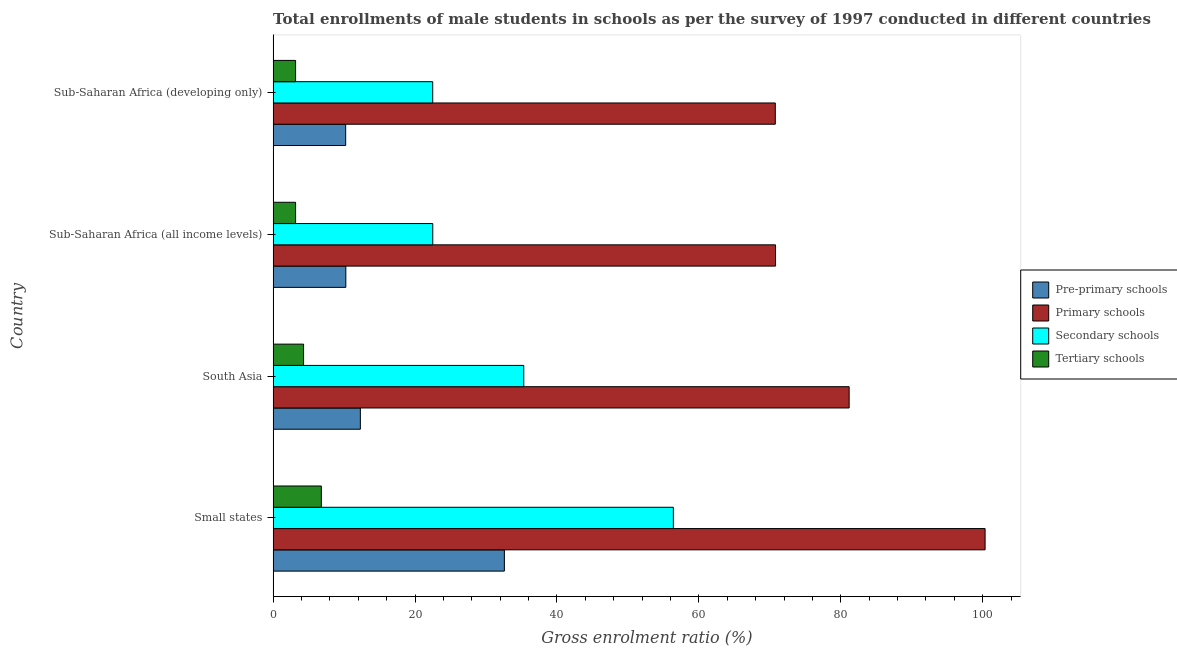How many different coloured bars are there?
Provide a short and direct response. 4. How many groups of bars are there?
Offer a very short reply. 4. Are the number of bars per tick equal to the number of legend labels?
Your response must be concise. Yes. Are the number of bars on each tick of the Y-axis equal?
Offer a terse response. Yes. How many bars are there on the 1st tick from the bottom?
Make the answer very short. 4. What is the label of the 3rd group of bars from the top?
Make the answer very short. South Asia. In how many cases, is the number of bars for a given country not equal to the number of legend labels?
Make the answer very short. 0. What is the gross enrolment ratio(male) in pre-primary schools in Sub-Saharan Africa (all income levels)?
Your answer should be compact. 10.25. Across all countries, what is the maximum gross enrolment ratio(male) in pre-primary schools?
Your answer should be very brief. 32.59. Across all countries, what is the minimum gross enrolment ratio(male) in pre-primary schools?
Your answer should be compact. 10.22. In which country was the gross enrolment ratio(male) in tertiary schools maximum?
Provide a short and direct response. Small states. In which country was the gross enrolment ratio(male) in pre-primary schools minimum?
Provide a short and direct response. Sub-Saharan Africa (developing only). What is the total gross enrolment ratio(male) in pre-primary schools in the graph?
Ensure brevity in your answer.  65.36. What is the difference between the gross enrolment ratio(male) in primary schools in Small states and that in Sub-Saharan Africa (all income levels)?
Provide a short and direct response. 29.53. What is the difference between the gross enrolment ratio(male) in pre-primary schools in Sub-Saharan Africa (all income levels) and the gross enrolment ratio(male) in primary schools in Sub-Saharan Africa (developing only)?
Give a very brief answer. -60.52. What is the average gross enrolment ratio(male) in pre-primary schools per country?
Provide a short and direct response. 16.34. What is the difference between the gross enrolment ratio(male) in tertiary schools and gross enrolment ratio(male) in secondary schools in Sub-Saharan Africa (developing only)?
Make the answer very short. -19.32. Is the difference between the gross enrolment ratio(male) in pre-primary schools in South Asia and Sub-Saharan Africa (all income levels) greater than the difference between the gross enrolment ratio(male) in secondary schools in South Asia and Sub-Saharan Africa (all income levels)?
Your response must be concise. No. What is the difference between the highest and the second highest gross enrolment ratio(male) in primary schools?
Offer a terse response. 19.16. What is the difference between the highest and the lowest gross enrolment ratio(male) in primary schools?
Your answer should be very brief. 29.57. In how many countries, is the gross enrolment ratio(male) in secondary schools greater than the average gross enrolment ratio(male) in secondary schools taken over all countries?
Provide a short and direct response. 2. What does the 4th bar from the top in South Asia represents?
Offer a terse response. Pre-primary schools. What does the 4th bar from the bottom in South Asia represents?
Provide a succinct answer. Tertiary schools. Is it the case that in every country, the sum of the gross enrolment ratio(male) in pre-primary schools and gross enrolment ratio(male) in primary schools is greater than the gross enrolment ratio(male) in secondary schools?
Provide a short and direct response. Yes. Are the values on the major ticks of X-axis written in scientific E-notation?
Give a very brief answer. No. Does the graph contain any zero values?
Offer a terse response. No. Where does the legend appear in the graph?
Provide a short and direct response. Center right. What is the title of the graph?
Your answer should be compact. Total enrollments of male students in schools as per the survey of 1997 conducted in different countries. Does "Public sector management" appear as one of the legend labels in the graph?
Your answer should be compact. No. What is the label or title of the X-axis?
Your response must be concise. Gross enrolment ratio (%). What is the label or title of the Y-axis?
Provide a short and direct response. Country. What is the Gross enrolment ratio (%) of Pre-primary schools in Small states?
Offer a very short reply. 32.59. What is the Gross enrolment ratio (%) in Primary schools in Small states?
Your answer should be compact. 100.33. What is the Gross enrolment ratio (%) of Secondary schools in Small states?
Offer a very short reply. 56.4. What is the Gross enrolment ratio (%) of Tertiary schools in Small states?
Your answer should be very brief. 6.79. What is the Gross enrolment ratio (%) of Pre-primary schools in South Asia?
Offer a very short reply. 12.29. What is the Gross enrolment ratio (%) of Primary schools in South Asia?
Ensure brevity in your answer.  81.18. What is the Gross enrolment ratio (%) in Secondary schools in South Asia?
Your answer should be very brief. 35.32. What is the Gross enrolment ratio (%) in Tertiary schools in South Asia?
Provide a short and direct response. 4.29. What is the Gross enrolment ratio (%) in Pre-primary schools in Sub-Saharan Africa (all income levels)?
Make the answer very short. 10.25. What is the Gross enrolment ratio (%) of Primary schools in Sub-Saharan Africa (all income levels)?
Your answer should be very brief. 70.8. What is the Gross enrolment ratio (%) in Secondary schools in Sub-Saharan Africa (all income levels)?
Your answer should be very brief. 22.5. What is the Gross enrolment ratio (%) of Tertiary schools in Sub-Saharan Africa (all income levels)?
Your response must be concise. 3.17. What is the Gross enrolment ratio (%) in Pre-primary schools in Sub-Saharan Africa (developing only)?
Provide a succinct answer. 10.22. What is the Gross enrolment ratio (%) in Primary schools in Sub-Saharan Africa (developing only)?
Make the answer very short. 70.77. What is the Gross enrolment ratio (%) of Secondary schools in Sub-Saharan Africa (developing only)?
Provide a succinct answer. 22.49. What is the Gross enrolment ratio (%) of Tertiary schools in Sub-Saharan Africa (developing only)?
Ensure brevity in your answer.  3.17. Across all countries, what is the maximum Gross enrolment ratio (%) of Pre-primary schools?
Give a very brief answer. 32.59. Across all countries, what is the maximum Gross enrolment ratio (%) in Primary schools?
Provide a short and direct response. 100.33. Across all countries, what is the maximum Gross enrolment ratio (%) in Secondary schools?
Give a very brief answer. 56.4. Across all countries, what is the maximum Gross enrolment ratio (%) in Tertiary schools?
Provide a short and direct response. 6.79. Across all countries, what is the minimum Gross enrolment ratio (%) of Pre-primary schools?
Ensure brevity in your answer.  10.22. Across all countries, what is the minimum Gross enrolment ratio (%) in Primary schools?
Make the answer very short. 70.77. Across all countries, what is the minimum Gross enrolment ratio (%) in Secondary schools?
Offer a terse response. 22.49. Across all countries, what is the minimum Gross enrolment ratio (%) of Tertiary schools?
Ensure brevity in your answer.  3.17. What is the total Gross enrolment ratio (%) in Pre-primary schools in the graph?
Your answer should be very brief. 65.36. What is the total Gross enrolment ratio (%) of Primary schools in the graph?
Your response must be concise. 323.08. What is the total Gross enrolment ratio (%) in Secondary schools in the graph?
Provide a succinct answer. 136.71. What is the total Gross enrolment ratio (%) of Tertiary schools in the graph?
Give a very brief answer. 17.42. What is the difference between the Gross enrolment ratio (%) of Pre-primary schools in Small states and that in South Asia?
Your answer should be very brief. 20.29. What is the difference between the Gross enrolment ratio (%) in Primary schools in Small states and that in South Asia?
Offer a very short reply. 19.16. What is the difference between the Gross enrolment ratio (%) of Secondary schools in Small states and that in South Asia?
Your answer should be compact. 21.08. What is the difference between the Gross enrolment ratio (%) in Tertiary schools in Small states and that in South Asia?
Your response must be concise. 2.5. What is the difference between the Gross enrolment ratio (%) in Pre-primary schools in Small states and that in Sub-Saharan Africa (all income levels)?
Offer a very short reply. 22.34. What is the difference between the Gross enrolment ratio (%) of Primary schools in Small states and that in Sub-Saharan Africa (all income levels)?
Give a very brief answer. 29.53. What is the difference between the Gross enrolment ratio (%) of Secondary schools in Small states and that in Sub-Saharan Africa (all income levels)?
Ensure brevity in your answer.  33.91. What is the difference between the Gross enrolment ratio (%) in Tertiary schools in Small states and that in Sub-Saharan Africa (all income levels)?
Give a very brief answer. 3.63. What is the difference between the Gross enrolment ratio (%) of Pre-primary schools in Small states and that in Sub-Saharan Africa (developing only)?
Your response must be concise. 22.36. What is the difference between the Gross enrolment ratio (%) of Primary schools in Small states and that in Sub-Saharan Africa (developing only)?
Give a very brief answer. 29.57. What is the difference between the Gross enrolment ratio (%) of Secondary schools in Small states and that in Sub-Saharan Africa (developing only)?
Your answer should be compact. 33.91. What is the difference between the Gross enrolment ratio (%) of Tertiary schools in Small states and that in Sub-Saharan Africa (developing only)?
Ensure brevity in your answer.  3.63. What is the difference between the Gross enrolment ratio (%) of Pre-primary schools in South Asia and that in Sub-Saharan Africa (all income levels)?
Give a very brief answer. 2.05. What is the difference between the Gross enrolment ratio (%) of Primary schools in South Asia and that in Sub-Saharan Africa (all income levels)?
Your answer should be compact. 10.37. What is the difference between the Gross enrolment ratio (%) in Secondary schools in South Asia and that in Sub-Saharan Africa (all income levels)?
Offer a terse response. 12.82. What is the difference between the Gross enrolment ratio (%) of Tertiary schools in South Asia and that in Sub-Saharan Africa (all income levels)?
Your answer should be very brief. 1.13. What is the difference between the Gross enrolment ratio (%) of Pre-primary schools in South Asia and that in Sub-Saharan Africa (developing only)?
Provide a short and direct response. 2.07. What is the difference between the Gross enrolment ratio (%) of Primary schools in South Asia and that in Sub-Saharan Africa (developing only)?
Make the answer very short. 10.41. What is the difference between the Gross enrolment ratio (%) in Secondary schools in South Asia and that in Sub-Saharan Africa (developing only)?
Ensure brevity in your answer.  12.83. What is the difference between the Gross enrolment ratio (%) of Tertiary schools in South Asia and that in Sub-Saharan Africa (developing only)?
Give a very brief answer. 1.12. What is the difference between the Gross enrolment ratio (%) in Pre-primary schools in Sub-Saharan Africa (all income levels) and that in Sub-Saharan Africa (developing only)?
Offer a very short reply. 0.02. What is the difference between the Gross enrolment ratio (%) in Primary schools in Sub-Saharan Africa (all income levels) and that in Sub-Saharan Africa (developing only)?
Offer a terse response. 0.03. What is the difference between the Gross enrolment ratio (%) in Secondary schools in Sub-Saharan Africa (all income levels) and that in Sub-Saharan Africa (developing only)?
Your answer should be compact. 0.01. What is the difference between the Gross enrolment ratio (%) in Tertiary schools in Sub-Saharan Africa (all income levels) and that in Sub-Saharan Africa (developing only)?
Ensure brevity in your answer.  -0. What is the difference between the Gross enrolment ratio (%) of Pre-primary schools in Small states and the Gross enrolment ratio (%) of Primary schools in South Asia?
Make the answer very short. -48.59. What is the difference between the Gross enrolment ratio (%) in Pre-primary schools in Small states and the Gross enrolment ratio (%) in Secondary schools in South Asia?
Offer a very short reply. -2.73. What is the difference between the Gross enrolment ratio (%) in Pre-primary schools in Small states and the Gross enrolment ratio (%) in Tertiary schools in South Asia?
Ensure brevity in your answer.  28.3. What is the difference between the Gross enrolment ratio (%) of Primary schools in Small states and the Gross enrolment ratio (%) of Secondary schools in South Asia?
Offer a terse response. 65.01. What is the difference between the Gross enrolment ratio (%) in Primary schools in Small states and the Gross enrolment ratio (%) in Tertiary schools in South Asia?
Provide a short and direct response. 96.04. What is the difference between the Gross enrolment ratio (%) of Secondary schools in Small states and the Gross enrolment ratio (%) of Tertiary schools in South Asia?
Your answer should be compact. 52.11. What is the difference between the Gross enrolment ratio (%) in Pre-primary schools in Small states and the Gross enrolment ratio (%) in Primary schools in Sub-Saharan Africa (all income levels)?
Keep it short and to the point. -38.21. What is the difference between the Gross enrolment ratio (%) of Pre-primary schools in Small states and the Gross enrolment ratio (%) of Secondary schools in Sub-Saharan Africa (all income levels)?
Your answer should be compact. 10.09. What is the difference between the Gross enrolment ratio (%) of Pre-primary schools in Small states and the Gross enrolment ratio (%) of Tertiary schools in Sub-Saharan Africa (all income levels)?
Give a very brief answer. 29.42. What is the difference between the Gross enrolment ratio (%) of Primary schools in Small states and the Gross enrolment ratio (%) of Secondary schools in Sub-Saharan Africa (all income levels)?
Make the answer very short. 77.84. What is the difference between the Gross enrolment ratio (%) of Primary schools in Small states and the Gross enrolment ratio (%) of Tertiary schools in Sub-Saharan Africa (all income levels)?
Make the answer very short. 97.17. What is the difference between the Gross enrolment ratio (%) of Secondary schools in Small states and the Gross enrolment ratio (%) of Tertiary schools in Sub-Saharan Africa (all income levels)?
Provide a succinct answer. 53.24. What is the difference between the Gross enrolment ratio (%) in Pre-primary schools in Small states and the Gross enrolment ratio (%) in Primary schools in Sub-Saharan Africa (developing only)?
Your answer should be compact. -38.18. What is the difference between the Gross enrolment ratio (%) of Pre-primary schools in Small states and the Gross enrolment ratio (%) of Secondary schools in Sub-Saharan Africa (developing only)?
Your answer should be very brief. 10.1. What is the difference between the Gross enrolment ratio (%) of Pre-primary schools in Small states and the Gross enrolment ratio (%) of Tertiary schools in Sub-Saharan Africa (developing only)?
Offer a very short reply. 29.42. What is the difference between the Gross enrolment ratio (%) in Primary schools in Small states and the Gross enrolment ratio (%) in Secondary schools in Sub-Saharan Africa (developing only)?
Your answer should be compact. 77.84. What is the difference between the Gross enrolment ratio (%) of Primary schools in Small states and the Gross enrolment ratio (%) of Tertiary schools in Sub-Saharan Africa (developing only)?
Give a very brief answer. 97.17. What is the difference between the Gross enrolment ratio (%) in Secondary schools in Small states and the Gross enrolment ratio (%) in Tertiary schools in Sub-Saharan Africa (developing only)?
Provide a succinct answer. 53.24. What is the difference between the Gross enrolment ratio (%) of Pre-primary schools in South Asia and the Gross enrolment ratio (%) of Primary schools in Sub-Saharan Africa (all income levels)?
Give a very brief answer. -58.51. What is the difference between the Gross enrolment ratio (%) in Pre-primary schools in South Asia and the Gross enrolment ratio (%) in Secondary schools in Sub-Saharan Africa (all income levels)?
Offer a very short reply. -10.2. What is the difference between the Gross enrolment ratio (%) in Pre-primary schools in South Asia and the Gross enrolment ratio (%) in Tertiary schools in Sub-Saharan Africa (all income levels)?
Provide a short and direct response. 9.13. What is the difference between the Gross enrolment ratio (%) of Primary schools in South Asia and the Gross enrolment ratio (%) of Secondary schools in Sub-Saharan Africa (all income levels)?
Your response must be concise. 58.68. What is the difference between the Gross enrolment ratio (%) in Primary schools in South Asia and the Gross enrolment ratio (%) in Tertiary schools in Sub-Saharan Africa (all income levels)?
Provide a short and direct response. 78.01. What is the difference between the Gross enrolment ratio (%) of Secondary schools in South Asia and the Gross enrolment ratio (%) of Tertiary schools in Sub-Saharan Africa (all income levels)?
Keep it short and to the point. 32.16. What is the difference between the Gross enrolment ratio (%) in Pre-primary schools in South Asia and the Gross enrolment ratio (%) in Primary schools in Sub-Saharan Africa (developing only)?
Offer a terse response. -58.47. What is the difference between the Gross enrolment ratio (%) in Pre-primary schools in South Asia and the Gross enrolment ratio (%) in Secondary schools in Sub-Saharan Africa (developing only)?
Your response must be concise. -10.2. What is the difference between the Gross enrolment ratio (%) of Pre-primary schools in South Asia and the Gross enrolment ratio (%) of Tertiary schools in Sub-Saharan Africa (developing only)?
Ensure brevity in your answer.  9.13. What is the difference between the Gross enrolment ratio (%) of Primary schools in South Asia and the Gross enrolment ratio (%) of Secondary schools in Sub-Saharan Africa (developing only)?
Offer a very short reply. 58.69. What is the difference between the Gross enrolment ratio (%) of Primary schools in South Asia and the Gross enrolment ratio (%) of Tertiary schools in Sub-Saharan Africa (developing only)?
Keep it short and to the point. 78.01. What is the difference between the Gross enrolment ratio (%) of Secondary schools in South Asia and the Gross enrolment ratio (%) of Tertiary schools in Sub-Saharan Africa (developing only)?
Offer a very short reply. 32.16. What is the difference between the Gross enrolment ratio (%) in Pre-primary schools in Sub-Saharan Africa (all income levels) and the Gross enrolment ratio (%) in Primary schools in Sub-Saharan Africa (developing only)?
Your answer should be compact. -60.52. What is the difference between the Gross enrolment ratio (%) of Pre-primary schools in Sub-Saharan Africa (all income levels) and the Gross enrolment ratio (%) of Secondary schools in Sub-Saharan Africa (developing only)?
Make the answer very short. -12.24. What is the difference between the Gross enrolment ratio (%) of Pre-primary schools in Sub-Saharan Africa (all income levels) and the Gross enrolment ratio (%) of Tertiary schools in Sub-Saharan Africa (developing only)?
Provide a succinct answer. 7.08. What is the difference between the Gross enrolment ratio (%) in Primary schools in Sub-Saharan Africa (all income levels) and the Gross enrolment ratio (%) in Secondary schools in Sub-Saharan Africa (developing only)?
Ensure brevity in your answer.  48.31. What is the difference between the Gross enrolment ratio (%) of Primary schools in Sub-Saharan Africa (all income levels) and the Gross enrolment ratio (%) of Tertiary schools in Sub-Saharan Africa (developing only)?
Offer a terse response. 67.64. What is the difference between the Gross enrolment ratio (%) in Secondary schools in Sub-Saharan Africa (all income levels) and the Gross enrolment ratio (%) in Tertiary schools in Sub-Saharan Africa (developing only)?
Offer a terse response. 19.33. What is the average Gross enrolment ratio (%) in Pre-primary schools per country?
Give a very brief answer. 16.34. What is the average Gross enrolment ratio (%) in Primary schools per country?
Give a very brief answer. 80.77. What is the average Gross enrolment ratio (%) of Secondary schools per country?
Your response must be concise. 34.18. What is the average Gross enrolment ratio (%) of Tertiary schools per country?
Your answer should be very brief. 4.35. What is the difference between the Gross enrolment ratio (%) of Pre-primary schools and Gross enrolment ratio (%) of Primary schools in Small states?
Give a very brief answer. -67.75. What is the difference between the Gross enrolment ratio (%) of Pre-primary schools and Gross enrolment ratio (%) of Secondary schools in Small states?
Provide a short and direct response. -23.81. What is the difference between the Gross enrolment ratio (%) of Pre-primary schools and Gross enrolment ratio (%) of Tertiary schools in Small states?
Your response must be concise. 25.8. What is the difference between the Gross enrolment ratio (%) of Primary schools and Gross enrolment ratio (%) of Secondary schools in Small states?
Give a very brief answer. 43.93. What is the difference between the Gross enrolment ratio (%) in Primary schools and Gross enrolment ratio (%) in Tertiary schools in Small states?
Provide a short and direct response. 93.54. What is the difference between the Gross enrolment ratio (%) in Secondary schools and Gross enrolment ratio (%) in Tertiary schools in Small states?
Give a very brief answer. 49.61. What is the difference between the Gross enrolment ratio (%) of Pre-primary schools and Gross enrolment ratio (%) of Primary schools in South Asia?
Give a very brief answer. -68.88. What is the difference between the Gross enrolment ratio (%) in Pre-primary schools and Gross enrolment ratio (%) in Secondary schools in South Asia?
Ensure brevity in your answer.  -23.03. What is the difference between the Gross enrolment ratio (%) of Pre-primary schools and Gross enrolment ratio (%) of Tertiary schools in South Asia?
Your response must be concise. 8. What is the difference between the Gross enrolment ratio (%) in Primary schools and Gross enrolment ratio (%) in Secondary schools in South Asia?
Your answer should be very brief. 45.85. What is the difference between the Gross enrolment ratio (%) in Primary schools and Gross enrolment ratio (%) in Tertiary schools in South Asia?
Keep it short and to the point. 76.88. What is the difference between the Gross enrolment ratio (%) in Secondary schools and Gross enrolment ratio (%) in Tertiary schools in South Asia?
Your response must be concise. 31.03. What is the difference between the Gross enrolment ratio (%) of Pre-primary schools and Gross enrolment ratio (%) of Primary schools in Sub-Saharan Africa (all income levels)?
Your answer should be compact. -60.56. What is the difference between the Gross enrolment ratio (%) in Pre-primary schools and Gross enrolment ratio (%) in Secondary schools in Sub-Saharan Africa (all income levels)?
Offer a very short reply. -12.25. What is the difference between the Gross enrolment ratio (%) of Pre-primary schools and Gross enrolment ratio (%) of Tertiary schools in Sub-Saharan Africa (all income levels)?
Offer a terse response. 7.08. What is the difference between the Gross enrolment ratio (%) in Primary schools and Gross enrolment ratio (%) in Secondary schools in Sub-Saharan Africa (all income levels)?
Provide a succinct answer. 48.3. What is the difference between the Gross enrolment ratio (%) in Primary schools and Gross enrolment ratio (%) in Tertiary schools in Sub-Saharan Africa (all income levels)?
Ensure brevity in your answer.  67.64. What is the difference between the Gross enrolment ratio (%) in Secondary schools and Gross enrolment ratio (%) in Tertiary schools in Sub-Saharan Africa (all income levels)?
Ensure brevity in your answer.  19.33. What is the difference between the Gross enrolment ratio (%) in Pre-primary schools and Gross enrolment ratio (%) in Primary schools in Sub-Saharan Africa (developing only)?
Your response must be concise. -60.54. What is the difference between the Gross enrolment ratio (%) of Pre-primary schools and Gross enrolment ratio (%) of Secondary schools in Sub-Saharan Africa (developing only)?
Provide a succinct answer. -12.27. What is the difference between the Gross enrolment ratio (%) in Pre-primary schools and Gross enrolment ratio (%) in Tertiary schools in Sub-Saharan Africa (developing only)?
Provide a short and direct response. 7.06. What is the difference between the Gross enrolment ratio (%) of Primary schools and Gross enrolment ratio (%) of Secondary schools in Sub-Saharan Africa (developing only)?
Your answer should be compact. 48.28. What is the difference between the Gross enrolment ratio (%) in Primary schools and Gross enrolment ratio (%) in Tertiary schools in Sub-Saharan Africa (developing only)?
Provide a short and direct response. 67.6. What is the difference between the Gross enrolment ratio (%) of Secondary schools and Gross enrolment ratio (%) of Tertiary schools in Sub-Saharan Africa (developing only)?
Offer a terse response. 19.32. What is the ratio of the Gross enrolment ratio (%) of Pre-primary schools in Small states to that in South Asia?
Ensure brevity in your answer.  2.65. What is the ratio of the Gross enrolment ratio (%) in Primary schools in Small states to that in South Asia?
Make the answer very short. 1.24. What is the ratio of the Gross enrolment ratio (%) of Secondary schools in Small states to that in South Asia?
Offer a terse response. 1.6. What is the ratio of the Gross enrolment ratio (%) in Tertiary schools in Small states to that in South Asia?
Provide a succinct answer. 1.58. What is the ratio of the Gross enrolment ratio (%) of Pre-primary schools in Small states to that in Sub-Saharan Africa (all income levels)?
Provide a succinct answer. 3.18. What is the ratio of the Gross enrolment ratio (%) of Primary schools in Small states to that in Sub-Saharan Africa (all income levels)?
Your answer should be compact. 1.42. What is the ratio of the Gross enrolment ratio (%) in Secondary schools in Small states to that in Sub-Saharan Africa (all income levels)?
Provide a short and direct response. 2.51. What is the ratio of the Gross enrolment ratio (%) in Tertiary schools in Small states to that in Sub-Saharan Africa (all income levels)?
Make the answer very short. 2.15. What is the ratio of the Gross enrolment ratio (%) in Pre-primary schools in Small states to that in Sub-Saharan Africa (developing only)?
Your answer should be very brief. 3.19. What is the ratio of the Gross enrolment ratio (%) in Primary schools in Small states to that in Sub-Saharan Africa (developing only)?
Your response must be concise. 1.42. What is the ratio of the Gross enrolment ratio (%) in Secondary schools in Small states to that in Sub-Saharan Africa (developing only)?
Your answer should be very brief. 2.51. What is the ratio of the Gross enrolment ratio (%) of Tertiary schools in Small states to that in Sub-Saharan Africa (developing only)?
Provide a succinct answer. 2.14. What is the ratio of the Gross enrolment ratio (%) of Pre-primary schools in South Asia to that in Sub-Saharan Africa (all income levels)?
Your answer should be compact. 1.2. What is the ratio of the Gross enrolment ratio (%) in Primary schools in South Asia to that in Sub-Saharan Africa (all income levels)?
Provide a short and direct response. 1.15. What is the ratio of the Gross enrolment ratio (%) of Secondary schools in South Asia to that in Sub-Saharan Africa (all income levels)?
Ensure brevity in your answer.  1.57. What is the ratio of the Gross enrolment ratio (%) in Tertiary schools in South Asia to that in Sub-Saharan Africa (all income levels)?
Ensure brevity in your answer.  1.36. What is the ratio of the Gross enrolment ratio (%) in Pre-primary schools in South Asia to that in Sub-Saharan Africa (developing only)?
Your answer should be very brief. 1.2. What is the ratio of the Gross enrolment ratio (%) in Primary schools in South Asia to that in Sub-Saharan Africa (developing only)?
Make the answer very short. 1.15. What is the ratio of the Gross enrolment ratio (%) in Secondary schools in South Asia to that in Sub-Saharan Africa (developing only)?
Your answer should be very brief. 1.57. What is the ratio of the Gross enrolment ratio (%) in Tertiary schools in South Asia to that in Sub-Saharan Africa (developing only)?
Ensure brevity in your answer.  1.36. What is the ratio of the Gross enrolment ratio (%) in Primary schools in Sub-Saharan Africa (all income levels) to that in Sub-Saharan Africa (developing only)?
Your answer should be very brief. 1. What is the difference between the highest and the second highest Gross enrolment ratio (%) in Pre-primary schools?
Provide a short and direct response. 20.29. What is the difference between the highest and the second highest Gross enrolment ratio (%) of Primary schools?
Offer a very short reply. 19.16. What is the difference between the highest and the second highest Gross enrolment ratio (%) in Secondary schools?
Your answer should be very brief. 21.08. What is the difference between the highest and the second highest Gross enrolment ratio (%) in Tertiary schools?
Offer a very short reply. 2.5. What is the difference between the highest and the lowest Gross enrolment ratio (%) in Pre-primary schools?
Ensure brevity in your answer.  22.36. What is the difference between the highest and the lowest Gross enrolment ratio (%) in Primary schools?
Keep it short and to the point. 29.57. What is the difference between the highest and the lowest Gross enrolment ratio (%) of Secondary schools?
Your answer should be very brief. 33.91. What is the difference between the highest and the lowest Gross enrolment ratio (%) of Tertiary schools?
Your answer should be compact. 3.63. 